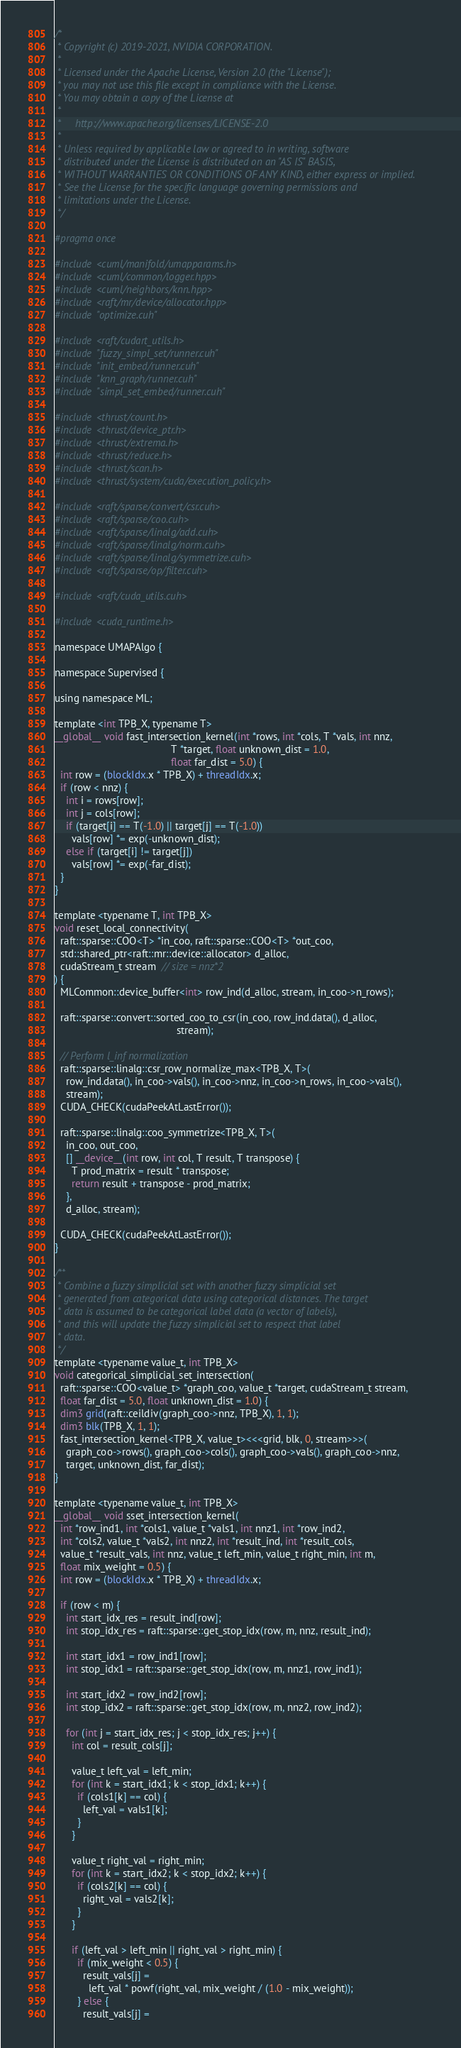<code> <loc_0><loc_0><loc_500><loc_500><_Cuda_>/*
 * Copyright (c) 2019-2021, NVIDIA CORPORATION.
 *
 * Licensed under the Apache License, Version 2.0 (the "License");
 * you may not use this file except in compliance with the License.
 * You may obtain a copy of the License at
 *
 *     http://www.apache.org/licenses/LICENSE-2.0
 *
 * Unless required by applicable law or agreed to in writing, software
 * distributed under the License is distributed on an "AS IS" BASIS,
 * WITHOUT WARRANTIES OR CONDITIONS OF ANY KIND, either express or implied.
 * See the License for the specific language governing permissions and
 * limitations under the License.
 */

#pragma once

#include <cuml/manifold/umapparams.h>
#include <cuml/common/logger.hpp>
#include <cuml/neighbors/knn.hpp>
#include <raft/mr/device/allocator.hpp>
#include "optimize.cuh"

#include <raft/cudart_utils.h>
#include "fuzzy_simpl_set/runner.cuh"
#include "init_embed/runner.cuh"
#include "knn_graph/runner.cuh"
#include "simpl_set_embed/runner.cuh"

#include <thrust/count.h>
#include <thrust/device_ptr.h>
#include <thrust/extrema.h>
#include <thrust/reduce.h>
#include <thrust/scan.h>
#include <thrust/system/cuda/execution_policy.h>

#include <raft/sparse/convert/csr.cuh>
#include <raft/sparse/coo.cuh>
#include <raft/sparse/linalg/add.cuh>
#include <raft/sparse/linalg/norm.cuh>
#include <raft/sparse/linalg/symmetrize.cuh>
#include <raft/sparse/op/filter.cuh>

#include <raft/cuda_utils.cuh>

#include <cuda_runtime.h>

namespace UMAPAlgo {

namespace Supervised {

using namespace ML;

template <int TPB_X, typename T>
__global__ void fast_intersection_kernel(int *rows, int *cols, T *vals, int nnz,
                                         T *target, float unknown_dist = 1.0,
                                         float far_dist = 5.0) {
  int row = (blockIdx.x * TPB_X) + threadIdx.x;
  if (row < nnz) {
    int i = rows[row];
    int j = cols[row];
    if (target[i] == T(-1.0) || target[j] == T(-1.0))
      vals[row] *= exp(-unknown_dist);
    else if (target[i] != target[j])
      vals[row] *= exp(-far_dist);
  }
}

template <typename T, int TPB_X>
void reset_local_connectivity(
  raft::sparse::COO<T> *in_coo, raft::sparse::COO<T> *out_coo,
  std::shared_ptr<raft::mr::device::allocator> d_alloc,
  cudaStream_t stream  // size = nnz*2
) {
  MLCommon::device_buffer<int> row_ind(d_alloc, stream, in_coo->n_rows);

  raft::sparse::convert::sorted_coo_to_csr(in_coo, row_ind.data(), d_alloc,
                                           stream);

  // Perform l_inf normalization
  raft::sparse::linalg::csr_row_normalize_max<TPB_X, T>(
    row_ind.data(), in_coo->vals(), in_coo->nnz, in_coo->n_rows, in_coo->vals(),
    stream);
  CUDA_CHECK(cudaPeekAtLastError());

  raft::sparse::linalg::coo_symmetrize<TPB_X, T>(
    in_coo, out_coo,
    [] __device__(int row, int col, T result, T transpose) {
      T prod_matrix = result * transpose;
      return result + transpose - prod_matrix;
    },
    d_alloc, stream);

  CUDA_CHECK(cudaPeekAtLastError());
}

/**
 * Combine a fuzzy simplicial set with another fuzzy simplicial set
 * generated from categorical data using categorical distances. The target
 * data is assumed to be categorical label data (a vector of labels),
 * and this will update the fuzzy simplicial set to respect that label
 * data.
 */
template <typename value_t, int TPB_X>
void categorical_simplicial_set_intersection(
  raft::sparse::COO<value_t> *graph_coo, value_t *target, cudaStream_t stream,
  float far_dist = 5.0, float unknown_dist = 1.0) {
  dim3 grid(raft::ceildiv(graph_coo->nnz, TPB_X), 1, 1);
  dim3 blk(TPB_X, 1, 1);
  fast_intersection_kernel<TPB_X, value_t><<<grid, blk, 0, stream>>>(
    graph_coo->rows(), graph_coo->cols(), graph_coo->vals(), graph_coo->nnz,
    target, unknown_dist, far_dist);
}

template <typename value_t, int TPB_X>
__global__ void sset_intersection_kernel(
  int *row_ind1, int *cols1, value_t *vals1, int nnz1, int *row_ind2,
  int *cols2, value_t *vals2, int nnz2, int *result_ind, int *result_cols,
  value_t *result_vals, int nnz, value_t left_min, value_t right_min, int m,
  float mix_weight = 0.5) {
  int row = (blockIdx.x * TPB_X) + threadIdx.x;

  if (row < m) {
    int start_idx_res = result_ind[row];
    int stop_idx_res = raft::sparse::get_stop_idx(row, m, nnz, result_ind);

    int start_idx1 = row_ind1[row];
    int stop_idx1 = raft::sparse::get_stop_idx(row, m, nnz1, row_ind1);

    int start_idx2 = row_ind2[row];
    int stop_idx2 = raft::sparse::get_stop_idx(row, m, nnz2, row_ind2);

    for (int j = start_idx_res; j < stop_idx_res; j++) {
      int col = result_cols[j];

      value_t left_val = left_min;
      for (int k = start_idx1; k < stop_idx1; k++) {
        if (cols1[k] == col) {
          left_val = vals1[k];
        }
      }

      value_t right_val = right_min;
      for (int k = start_idx2; k < stop_idx2; k++) {
        if (cols2[k] == col) {
          right_val = vals2[k];
        }
      }

      if (left_val > left_min || right_val > right_min) {
        if (mix_weight < 0.5) {
          result_vals[j] =
            left_val * powf(right_val, mix_weight / (1.0 - mix_weight));
        } else {
          result_vals[j] =</code> 